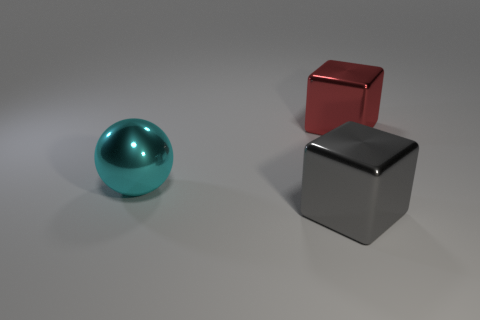Add 2 large spheres. How many objects exist? 5 Subtract all balls. How many objects are left? 2 Subtract 0 purple blocks. How many objects are left? 3 Subtract all red shiny balls. Subtract all big objects. How many objects are left? 0 Add 2 metal objects. How many metal objects are left? 5 Add 2 red metal objects. How many red metal objects exist? 3 